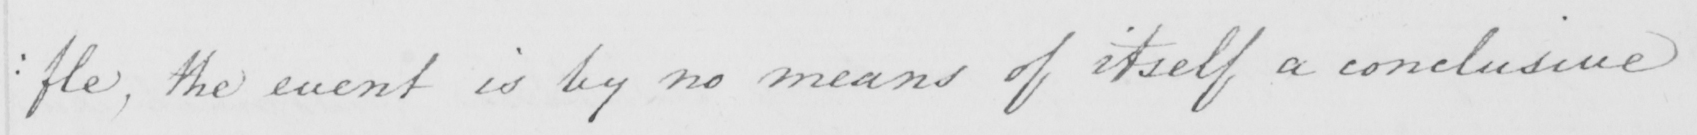Can you read and transcribe this handwriting? : fle , the event is by no means of itself a conclusive 